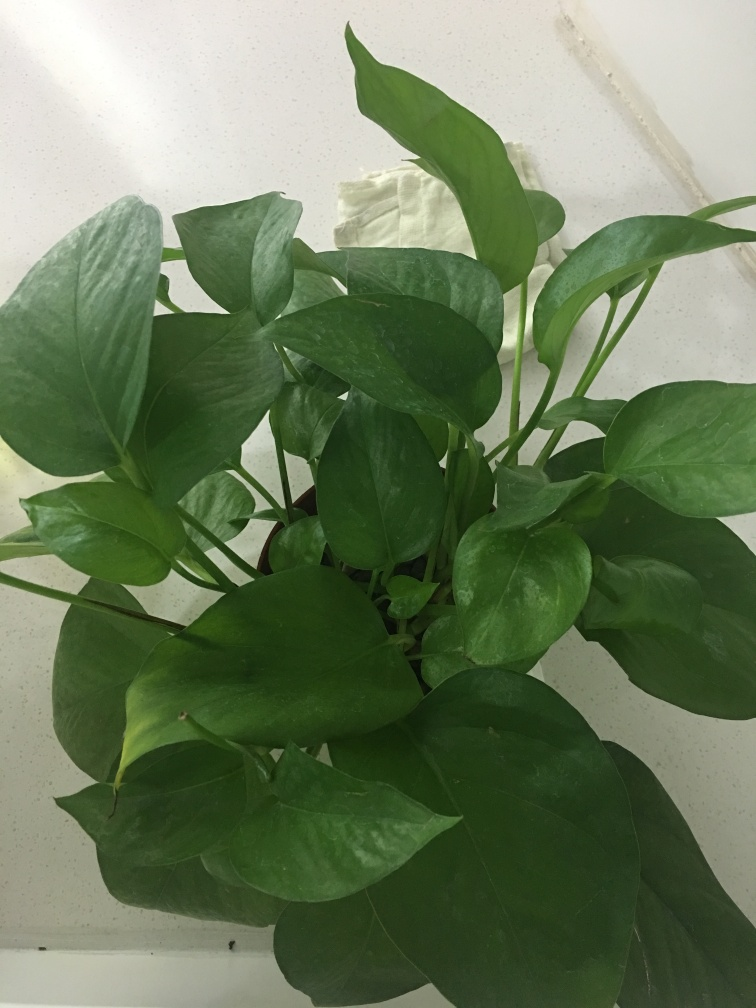What type of plant is shown in the image? The image depicts a green houseplant with heart-shaped leaves, which resembles the common type known as a pothos or devil's ivy. How can I tell if a plant like this is healthy? A healthy pothos plant will have vibrant green leaves, firm stems, and no visible signs of browning or wilting. Proper watering, adequate light, and the right environmental conditions play a crucial role in maintaining its health. 